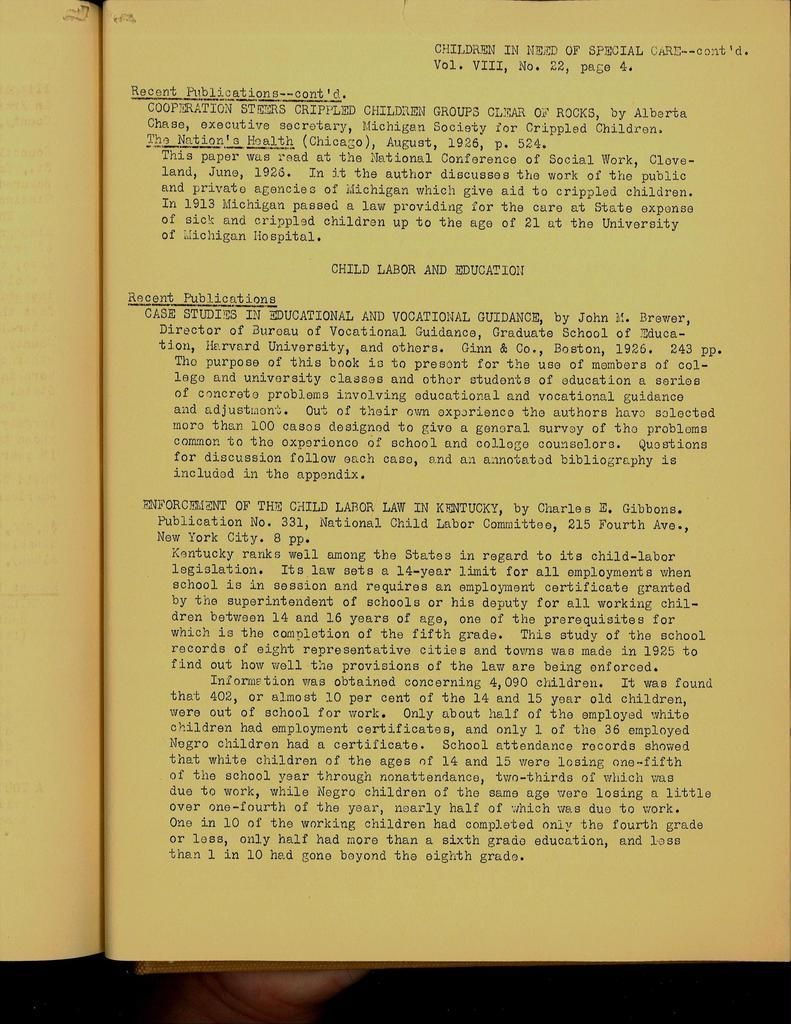<image>
Create a compact narrative representing the image presented. Yellowed, old type written text report about Child Labor and Education. 